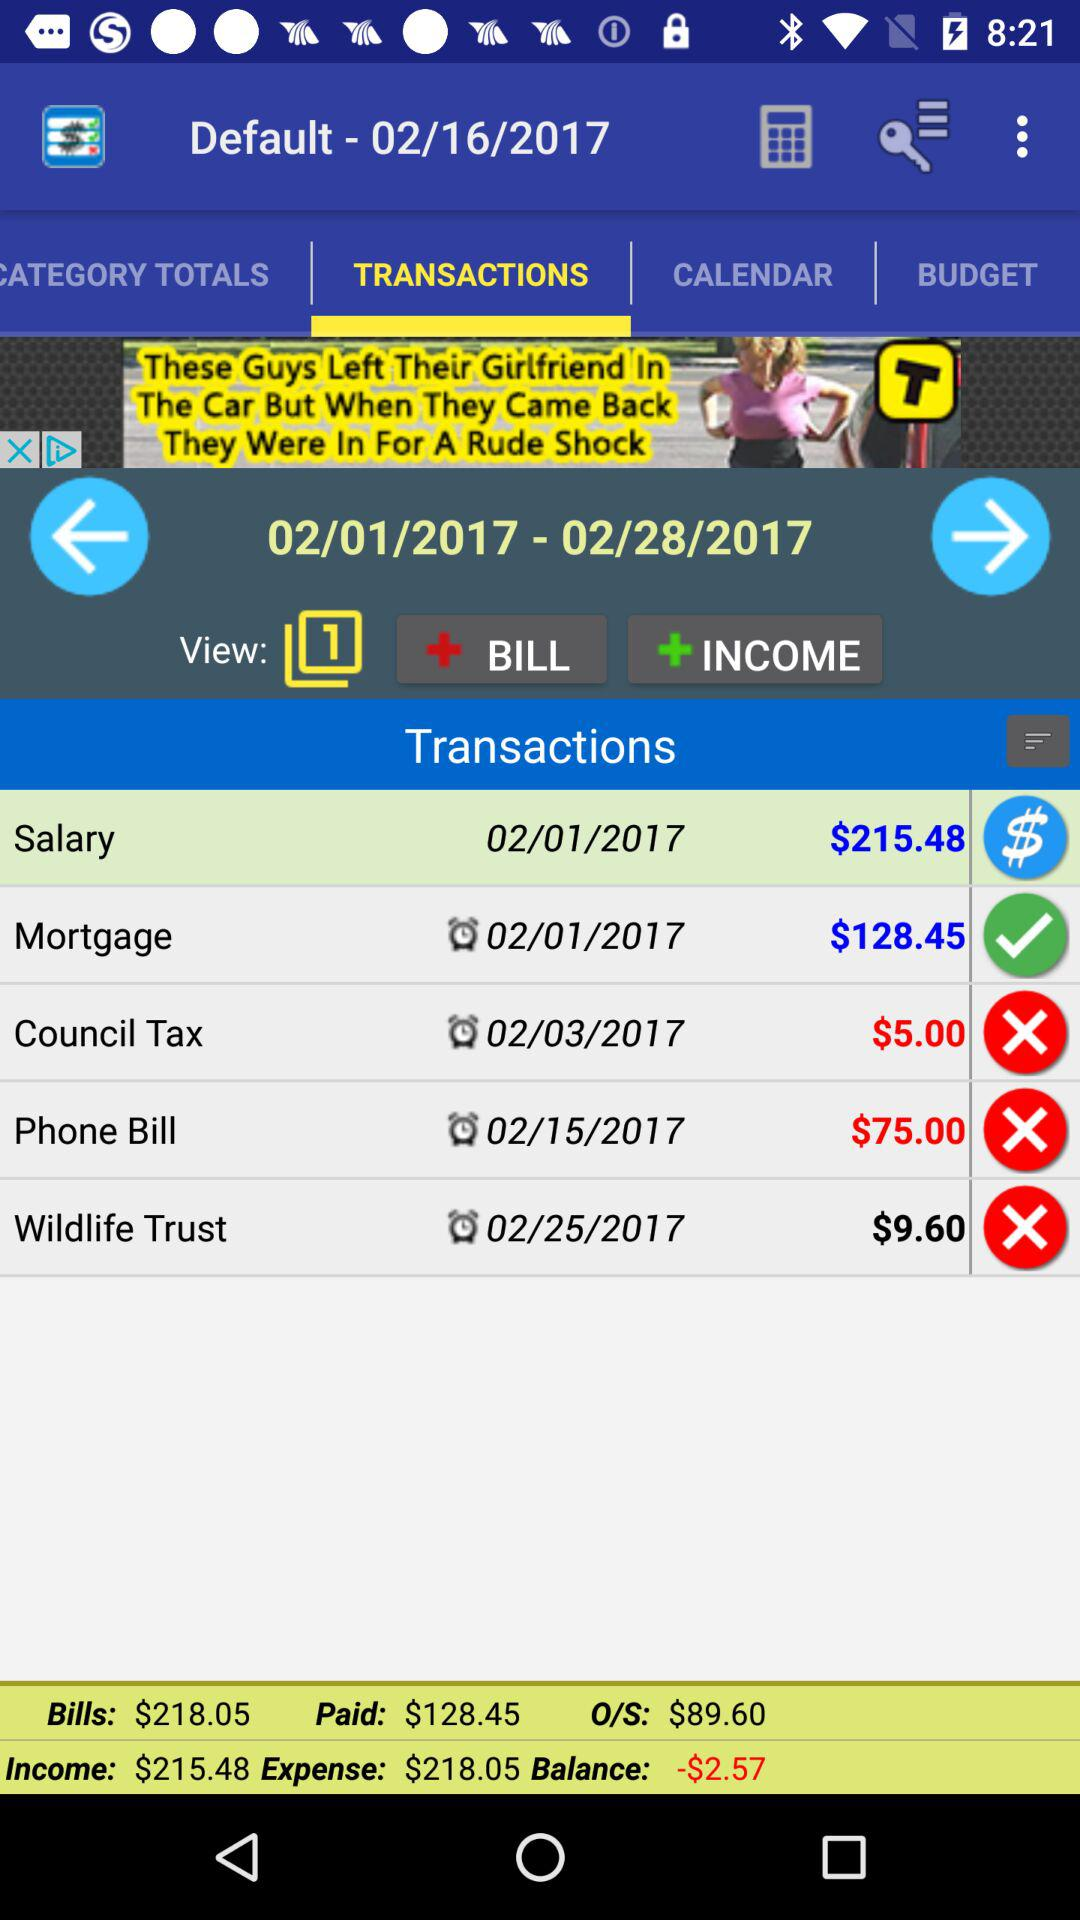Which tab is selected? The selected tab is "TRANSACTIONS". 